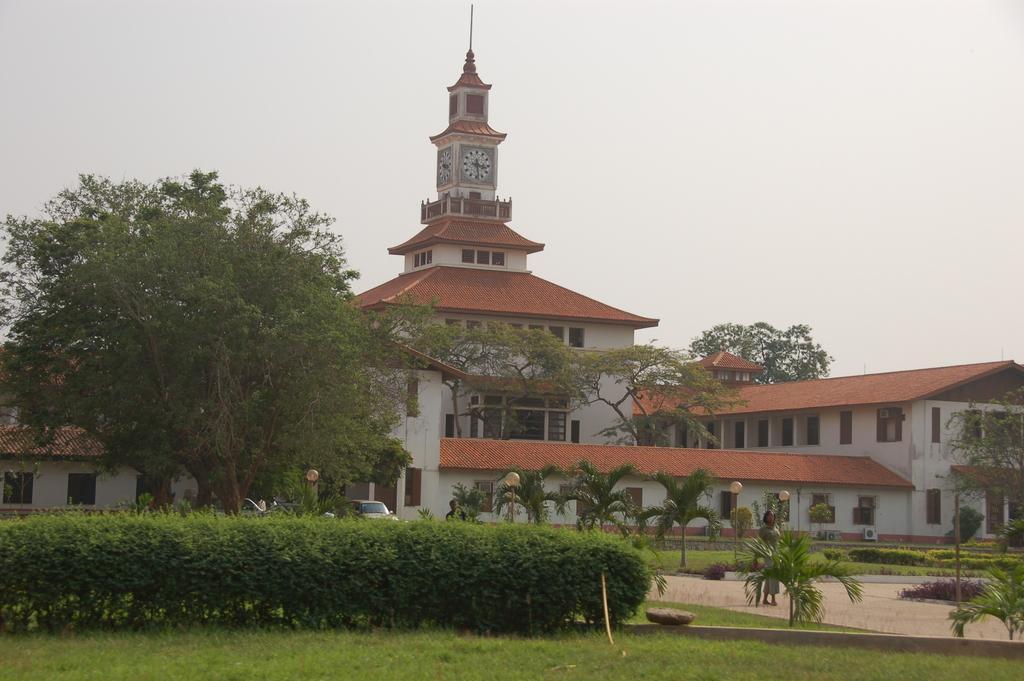Please provide a concise description of this image. In this image we can see a building and at the top of the building we can see the clock. There are some plants, trees and grass on the ground and we can see a person walking on the path and we can see some street lights. We can see a vehicle and there is a person standing and at the top we can see the sky. 